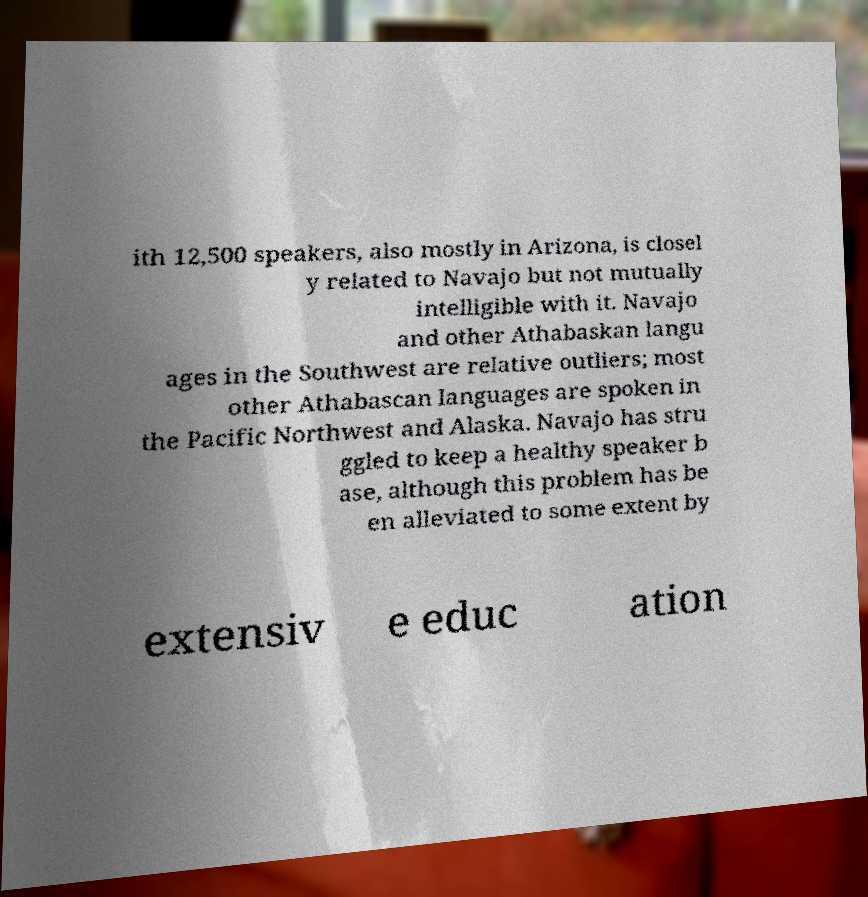Could you assist in decoding the text presented in this image and type it out clearly? ith 12,500 speakers, also mostly in Arizona, is closel y related to Navajo but not mutually intelligible with it. Navajo and other Athabaskan langu ages in the Southwest are relative outliers; most other Athabascan languages are spoken in the Pacific Northwest and Alaska. Navajo has stru ggled to keep a healthy speaker b ase, although this problem has be en alleviated to some extent by extensiv e educ ation 